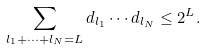<formula> <loc_0><loc_0><loc_500><loc_500>\sum _ { l _ { 1 } + \cdots + l _ { N } = L } d _ { l _ { 1 } } \cdots d _ { l _ { N } } \leq 2 ^ { L } .</formula> 